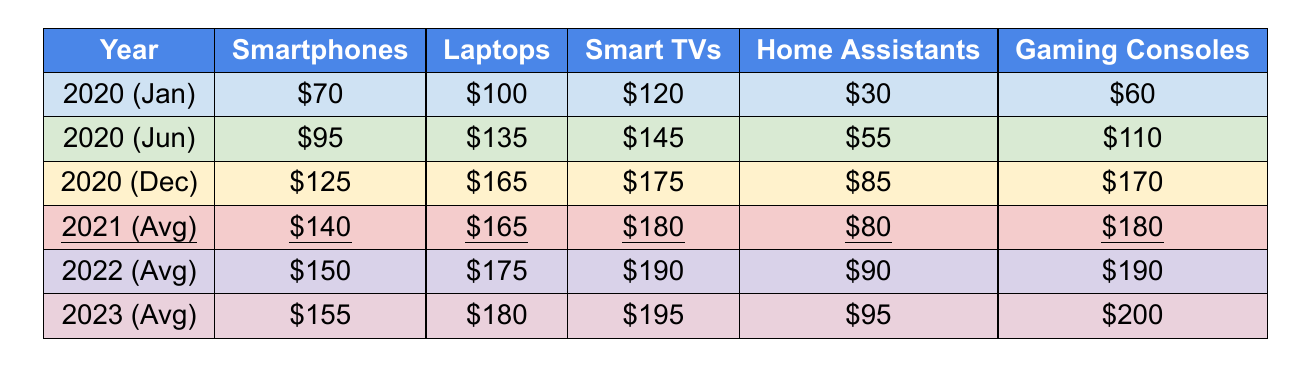What was the average expenditure on gaming consoles in 2021? The table shows the average expenditure on gaming consoles in 2021 as \$180.
Answer: \$180 What is the total average expenditure on home assistants from 2021 to 2023? The averages for home assistants are \$80 (2021), \$90 (2022), and \$95 (2023). Summing these gives \$80 + \$90 + \$95 = \$265.
Answer: \$265 Did the average expenditure on laptops increase from 2020 to 2021? Comparing the averages, laptops in 2020 (December) was \$165 and in 2021 it was \$165, showing no increase.
Answer: No Which month in 2020 had the highest expenditure on smart TVs? Looking through the data for 2020, December shows the highest expenditure on smart TVs at \$175.
Answer: December What is the difference in average expenditure on smartphones between 2022 and 2023? In 2022, the average for smartphones was \$150, and in 2023 it was \$155. The difference is \$155 - \$150 = \$5.
Answer: \$5 Which electronic category had the highest average expenditure in 2023? In 2023, the highest average expenditure is for gaming consoles at \$200.
Answer: Gaming Consoles How does the average expenditure on smart TVs from 2020 compare to that in 2023? In 2020 (December), the average was \$175, while in 2023 it was \$195. Thus, the average increased by \$195 - \$175 = \$20.
Answer: Increased by \$20 What is the average monthly expenditure on laptops for the year 2022? The average expenditure on laptops in 2022 is reported as \$175 in the table.
Answer: \$175 What are the average expenditures on electronics for 2022? The average expenditures for all categories in 2022 are: Smartphones: \$150, Laptops: \$175, Smart TVs: \$190, Home Assistants: \$90, and Gaming Consoles: \$190.
Answer: \$150 (Smartphones), \$175 (Laptops), \$190 (Smart TVs), \$90 (Home Assistants), \$190 (Gaming Consoles) What was the trend for gaming consoles from 2020 to 2023? The data shows an increase each year: from \$180 in 2021 to \$190 in 2022 and \$200 in 2023, indicating a consistent upward trend.
Answer: Upward trend 